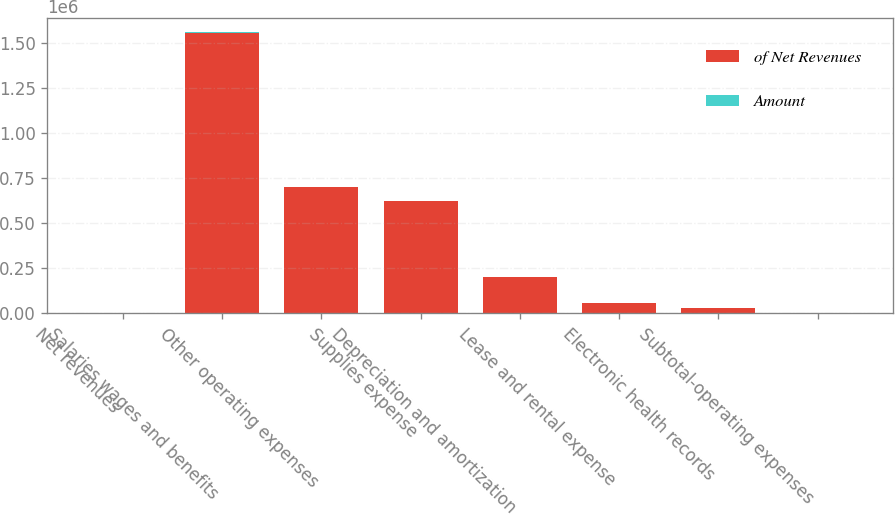Convert chart. <chart><loc_0><loc_0><loc_500><loc_500><stacked_bar_chart><ecel><fcel>Net revenues<fcel>Salaries wages and benefits<fcel>Other operating expenses<fcel>Supplies expense<fcel>Depreciation and amortization<fcel>Lease and rental expense<fcel>Electronic health records<fcel>Subtotal-operating expenses<nl><fcel>of Net Revenues<fcel>95.05<fcel>1.56047e+06<fcel>704108<fcel>624955<fcel>201536<fcel>58187<fcel>30038<fcel>95.05<nl><fcel>Amount<fcel>100<fcel>45.1<fcel>20.3<fcel>18.1<fcel>5.8<fcel>1.7<fcel>0.9<fcel>90.1<nl></chart> 